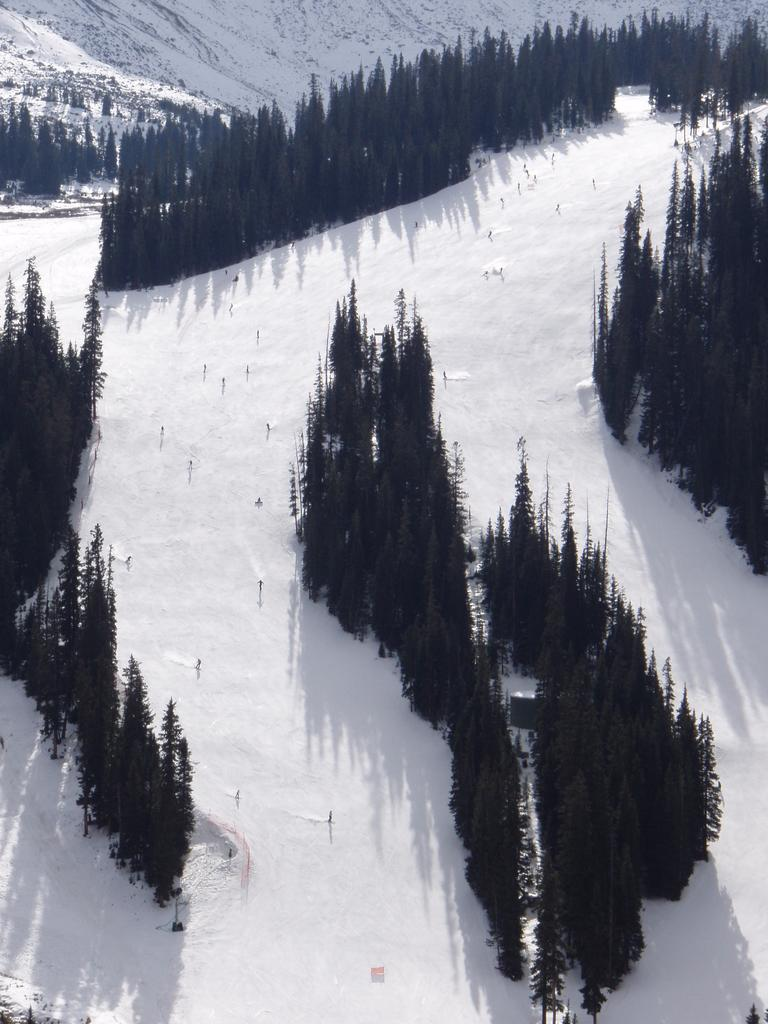What type of vegetation can be seen in the image? There are many trees in the image. What is the weather like in the image? There is snow visible in the image, which suggests a cold and snowy environment. What type of lipstick is the tree wearing in the image? There is no lipstick or trees wearing lipstick present in the image. Can you tell me who won the argument between the snowflakes in the image? There is no argument between snowflakes depicted in the image. 